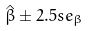Convert formula to latex. <formula><loc_0><loc_0><loc_500><loc_500>\hat { \beta } \pm 2 . 5 s e _ { \beta }</formula> 